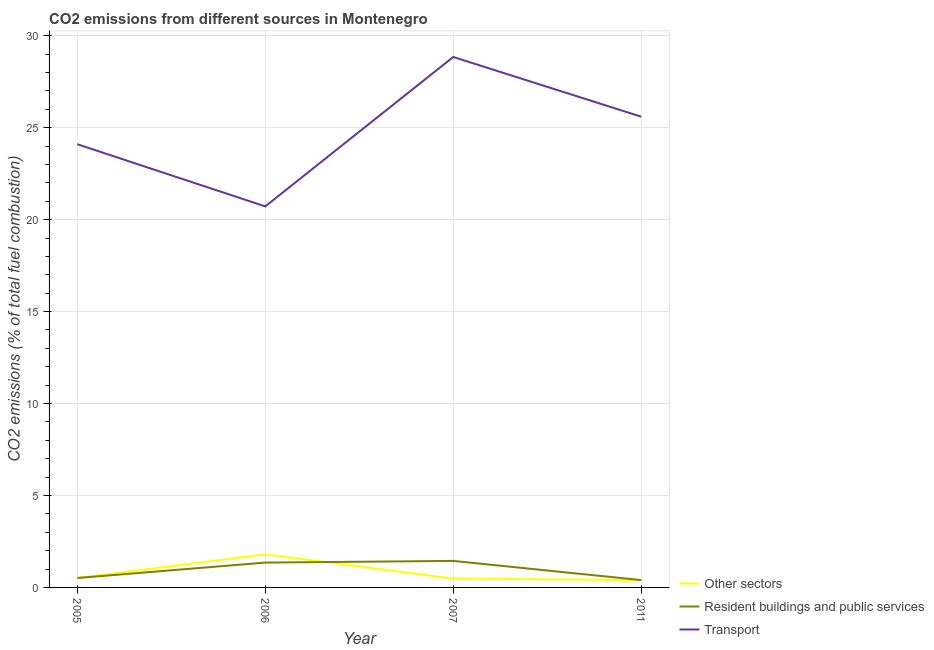What is the percentage of co2 emissions from resident buildings and public services in 2007?
Make the answer very short. 1.44. Across all years, what is the maximum percentage of co2 emissions from resident buildings and public services?
Your answer should be very brief. 1.44. Across all years, what is the minimum percentage of co2 emissions from other sectors?
Your answer should be very brief. 0.4. In which year was the percentage of co2 emissions from resident buildings and public services minimum?
Offer a very short reply. 2011. What is the total percentage of co2 emissions from resident buildings and public services in the graph?
Your answer should be compact. 3.71. What is the difference between the percentage of co2 emissions from resident buildings and public services in 2007 and that in 2011?
Offer a terse response. 1.04. What is the difference between the percentage of co2 emissions from resident buildings and public services in 2006 and the percentage of co2 emissions from transport in 2011?
Offer a terse response. -24.25. What is the average percentage of co2 emissions from other sectors per year?
Provide a short and direct response. 0.8. In the year 2007, what is the difference between the percentage of co2 emissions from other sectors and percentage of co2 emissions from transport?
Your answer should be very brief. -28.37. What is the ratio of the percentage of co2 emissions from transport in 2005 to that in 2011?
Your answer should be compact. 0.94. Is the percentage of co2 emissions from resident buildings and public services in 2005 less than that in 2007?
Make the answer very short. Yes. What is the difference between the highest and the second highest percentage of co2 emissions from resident buildings and public services?
Provide a short and direct response. 0.09. What is the difference between the highest and the lowest percentage of co2 emissions from other sectors?
Your answer should be very brief. 1.4. Does the percentage of co2 emissions from other sectors monotonically increase over the years?
Give a very brief answer. No. Is the percentage of co2 emissions from other sectors strictly greater than the percentage of co2 emissions from resident buildings and public services over the years?
Your answer should be compact. No. Is the percentage of co2 emissions from other sectors strictly less than the percentage of co2 emissions from resident buildings and public services over the years?
Offer a very short reply. No. What is the difference between two consecutive major ticks on the Y-axis?
Your answer should be compact. 5. Are the values on the major ticks of Y-axis written in scientific E-notation?
Ensure brevity in your answer.  No. Where does the legend appear in the graph?
Provide a succinct answer. Bottom right. How are the legend labels stacked?
Give a very brief answer. Vertical. What is the title of the graph?
Ensure brevity in your answer.  CO2 emissions from different sources in Montenegro. Does "Unemployment benefits" appear as one of the legend labels in the graph?
Offer a very short reply. No. What is the label or title of the X-axis?
Provide a succinct answer. Year. What is the label or title of the Y-axis?
Give a very brief answer. CO2 emissions (% of total fuel combustion). What is the CO2 emissions (% of total fuel combustion) in Other sectors in 2005?
Provide a succinct answer. 0.51. What is the CO2 emissions (% of total fuel combustion) of Resident buildings and public services in 2005?
Provide a short and direct response. 0.51. What is the CO2 emissions (% of total fuel combustion) in Transport in 2005?
Your answer should be compact. 24.1. What is the CO2 emissions (% of total fuel combustion) in Other sectors in 2006?
Keep it short and to the point. 1.8. What is the CO2 emissions (% of total fuel combustion) of Resident buildings and public services in 2006?
Give a very brief answer. 1.35. What is the CO2 emissions (% of total fuel combustion) in Transport in 2006?
Provide a short and direct response. 20.72. What is the CO2 emissions (% of total fuel combustion) in Other sectors in 2007?
Offer a very short reply. 0.48. What is the CO2 emissions (% of total fuel combustion) of Resident buildings and public services in 2007?
Your answer should be compact. 1.44. What is the CO2 emissions (% of total fuel combustion) of Transport in 2007?
Keep it short and to the point. 28.85. What is the CO2 emissions (% of total fuel combustion) in Transport in 2011?
Offer a terse response. 25.6. Across all years, what is the maximum CO2 emissions (% of total fuel combustion) in Other sectors?
Keep it short and to the point. 1.8. Across all years, what is the maximum CO2 emissions (% of total fuel combustion) in Resident buildings and public services?
Your answer should be compact. 1.44. Across all years, what is the maximum CO2 emissions (% of total fuel combustion) of Transport?
Your answer should be compact. 28.85. Across all years, what is the minimum CO2 emissions (% of total fuel combustion) of Other sectors?
Provide a succinct answer. 0.4. Across all years, what is the minimum CO2 emissions (% of total fuel combustion) of Transport?
Your response must be concise. 20.72. What is the total CO2 emissions (% of total fuel combustion) in Other sectors in the graph?
Offer a very short reply. 3.2. What is the total CO2 emissions (% of total fuel combustion) in Resident buildings and public services in the graph?
Offer a terse response. 3.71. What is the total CO2 emissions (% of total fuel combustion) in Transport in the graph?
Provide a succinct answer. 99.27. What is the difference between the CO2 emissions (% of total fuel combustion) of Other sectors in 2005 and that in 2006?
Provide a short and direct response. -1.29. What is the difference between the CO2 emissions (% of total fuel combustion) of Resident buildings and public services in 2005 and that in 2006?
Your response must be concise. -0.84. What is the difference between the CO2 emissions (% of total fuel combustion) in Transport in 2005 and that in 2006?
Your answer should be compact. 3.38. What is the difference between the CO2 emissions (% of total fuel combustion) in Other sectors in 2005 and that in 2007?
Offer a terse response. 0.03. What is the difference between the CO2 emissions (% of total fuel combustion) in Resident buildings and public services in 2005 and that in 2007?
Your answer should be very brief. -0.93. What is the difference between the CO2 emissions (% of total fuel combustion) in Transport in 2005 and that in 2007?
Offer a terse response. -4.74. What is the difference between the CO2 emissions (% of total fuel combustion) of Other sectors in 2005 and that in 2011?
Keep it short and to the point. 0.11. What is the difference between the CO2 emissions (% of total fuel combustion) of Resident buildings and public services in 2005 and that in 2011?
Provide a succinct answer. 0.11. What is the difference between the CO2 emissions (% of total fuel combustion) of Transport in 2005 and that in 2011?
Give a very brief answer. -1.5. What is the difference between the CO2 emissions (% of total fuel combustion) of Other sectors in 2006 and that in 2007?
Provide a short and direct response. 1.32. What is the difference between the CO2 emissions (% of total fuel combustion) in Resident buildings and public services in 2006 and that in 2007?
Provide a short and direct response. -0.09. What is the difference between the CO2 emissions (% of total fuel combustion) of Transport in 2006 and that in 2007?
Provide a succinct answer. -8.13. What is the difference between the CO2 emissions (% of total fuel combustion) of Other sectors in 2006 and that in 2011?
Provide a succinct answer. 1.4. What is the difference between the CO2 emissions (% of total fuel combustion) of Resident buildings and public services in 2006 and that in 2011?
Your response must be concise. 0.95. What is the difference between the CO2 emissions (% of total fuel combustion) in Transport in 2006 and that in 2011?
Give a very brief answer. -4.88. What is the difference between the CO2 emissions (% of total fuel combustion) of Other sectors in 2007 and that in 2011?
Give a very brief answer. 0.08. What is the difference between the CO2 emissions (% of total fuel combustion) of Resident buildings and public services in 2007 and that in 2011?
Provide a succinct answer. 1.04. What is the difference between the CO2 emissions (% of total fuel combustion) of Transport in 2007 and that in 2011?
Provide a short and direct response. 3.25. What is the difference between the CO2 emissions (% of total fuel combustion) of Other sectors in 2005 and the CO2 emissions (% of total fuel combustion) of Resident buildings and public services in 2006?
Offer a terse response. -0.84. What is the difference between the CO2 emissions (% of total fuel combustion) in Other sectors in 2005 and the CO2 emissions (% of total fuel combustion) in Transport in 2006?
Ensure brevity in your answer.  -20.21. What is the difference between the CO2 emissions (% of total fuel combustion) in Resident buildings and public services in 2005 and the CO2 emissions (% of total fuel combustion) in Transport in 2006?
Offer a very short reply. -20.21. What is the difference between the CO2 emissions (% of total fuel combustion) in Other sectors in 2005 and the CO2 emissions (% of total fuel combustion) in Resident buildings and public services in 2007?
Provide a short and direct response. -0.93. What is the difference between the CO2 emissions (% of total fuel combustion) of Other sectors in 2005 and the CO2 emissions (% of total fuel combustion) of Transport in 2007?
Offer a terse response. -28.33. What is the difference between the CO2 emissions (% of total fuel combustion) of Resident buildings and public services in 2005 and the CO2 emissions (% of total fuel combustion) of Transport in 2007?
Offer a terse response. -28.33. What is the difference between the CO2 emissions (% of total fuel combustion) of Other sectors in 2005 and the CO2 emissions (% of total fuel combustion) of Resident buildings and public services in 2011?
Your response must be concise. 0.11. What is the difference between the CO2 emissions (% of total fuel combustion) in Other sectors in 2005 and the CO2 emissions (% of total fuel combustion) in Transport in 2011?
Ensure brevity in your answer.  -25.09. What is the difference between the CO2 emissions (% of total fuel combustion) in Resident buildings and public services in 2005 and the CO2 emissions (% of total fuel combustion) in Transport in 2011?
Offer a very short reply. -25.09. What is the difference between the CO2 emissions (% of total fuel combustion) of Other sectors in 2006 and the CO2 emissions (% of total fuel combustion) of Resident buildings and public services in 2007?
Provide a short and direct response. 0.36. What is the difference between the CO2 emissions (% of total fuel combustion) in Other sectors in 2006 and the CO2 emissions (% of total fuel combustion) in Transport in 2007?
Your response must be concise. -27.04. What is the difference between the CO2 emissions (% of total fuel combustion) in Resident buildings and public services in 2006 and the CO2 emissions (% of total fuel combustion) in Transport in 2007?
Keep it short and to the point. -27.49. What is the difference between the CO2 emissions (% of total fuel combustion) of Other sectors in 2006 and the CO2 emissions (% of total fuel combustion) of Resident buildings and public services in 2011?
Keep it short and to the point. 1.4. What is the difference between the CO2 emissions (% of total fuel combustion) in Other sectors in 2006 and the CO2 emissions (% of total fuel combustion) in Transport in 2011?
Offer a terse response. -23.8. What is the difference between the CO2 emissions (% of total fuel combustion) of Resident buildings and public services in 2006 and the CO2 emissions (% of total fuel combustion) of Transport in 2011?
Provide a short and direct response. -24.25. What is the difference between the CO2 emissions (% of total fuel combustion) in Other sectors in 2007 and the CO2 emissions (% of total fuel combustion) in Resident buildings and public services in 2011?
Make the answer very short. 0.08. What is the difference between the CO2 emissions (% of total fuel combustion) of Other sectors in 2007 and the CO2 emissions (% of total fuel combustion) of Transport in 2011?
Make the answer very short. -25.12. What is the difference between the CO2 emissions (% of total fuel combustion) of Resident buildings and public services in 2007 and the CO2 emissions (% of total fuel combustion) of Transport in 2011?
Offer a terse response. -24.16. What is the average CO2 emissions (% of total fuel combustion) in Other sectors per year?
Make the answer very short. 0.8. What is the average CO2 emissions (% of total fuel combustion) in Resident buildings and public services per year?
Offer a very short reply. 0.93. What is the average CO2 emissions (% of total fuel combustion) of Transport per year?
Offer a terse response. 24.82. In the year 2005, what is the difference between the CO2 emissions (% of total fuel combustion) in Other sectors and CO2 emissions (% of total fuel combustion) in Resident buildings and public services?
Provide a succinct answer. 0. In the year 2005, what is the difference between the CO2 emissions (% of total fuel combustion) of Other sectors and CO2 emissions (% of total fuel combustion) of Transport?
Offer a terse response. -23.59. In the year 2005, what is the difference between the CO2 emissions (% of total fuel combustion) in Resident buildings and public services and CO2 emissions (% of total fuel combustion) in Transport?
Give a very brief answer. -23.59. In the year 2006, what is the difference between the CO2 emissions (% of total fuel combustion) of Other sectors and CO2 emissions (% of total fuel combustion) of Resident buildings and public services?
Your answer should be compact. 0.45. In the year 2006, what is the difference between the CO2 emissions (% of total fuel combustion) of Other sectors and CO2 emissions (% of total fuel combustion) of Transport?
Provide a short and direct response. -18.92. In the year 2006, what is the difference between the CO2 emissions (% of total fuel combustion) in Resident buildings and public services and CO2 emissions (% of total fuel combustion) in Transport?
Provide a short and direct response. -19.37. In the year 2007, what is the difference between the CO2 emissions (% of total fuel combustion) in Other sectors and CO2 emissions (% of total fuel combustion) in Resident buildings and public services?
Your response must be concise. -0.96. In the year 2007, what is the difference between the CO2 emissions (% of total fuel combustion) of Other sectors and CO2 emissions (% of total fuel combustion) of Transport?
Make the answer very short. -28.37. In the year 2007, what is the difference between the CO2 emissions (% of total fuel combustion) in Resident buildings and public services and CO2 emissions (% of total fuel combustion) in Transport?
Your answer should be very brief. -27.4. In the year 2011, what is the difference between the CO2 emissions (% of total fuel combustion) of Other sectors and CO2 emissions (% of total fuel combustion) of Resident buildings and public services?
Your answer should be compact. 0. In the year 2011, what is the difference between the CO2 emissions (% of total fuel combustion) of Other sectors and CO2 emissions (% of total fuel combustion) of Transport?
Make the answer very short. -25.2. In the year 2011, what is the difference between the CO2 emissions (% of total fuel combustion) in Resident buildings and public services and CO2 emissions (% of total fuel combustion) in Transport?
Your response must be concise. -25.2. What is the ratio of the CO2 emissions (% of total fuel combustion) in Other sectors in 2005 to that in 2006?
Give a very brief answer. 0.28. What is the ratio of the CO2 emissions (% of total fuel combustion) in Resident buildings and public services in 2005 to that in 2006?
Offer a very short reply. 0.38. What is the ratio of the CO2 emissions (% of total fuel combustion) in Transport in 2005 to that in 2006?
Offer a terse response. 1.16. What is the ratio of the CO2 emissions (% of total fuel combustion) in Other sectors in 2005 to that in 2007?
Offer a terse response. 1.07. What is the ratio of the CO2 emissions (% of total fuel combustion) in Resident buildings and public services in 2005 to that in 2007?
Provide a short and direct response. 0.36. What is the ratio of the CO2 emissions (% of total fuel combustion) in Transport in 2005 to that in 2007?
Your answer should be very brief. 0.84. What is the ratio of the CO2 emissions (% of total fuel combustion) in Other sectors in 2005 to that in 2011?
Your answer should be very brief. 1.28. What is the ratio of the CO2 emissions (% of total fuel combustion) of Resident buildings and public services in 2005 to that in 2011?
Keep it short and to the point. 1.28. What is the ratio of the CO2 emissions (% of total fuel combustion) of Transport in 2005 to that in 2011?
Offer a terse response. 0.94. What is the ratio of the CO2 emissions (% of total fuel combustion) in Other sectors in 2006 to that in 2007?
Your answer should be very brief. 3.75. What is the ratio of the CO2 emissions (% of total fuel combustion) of Resident buildings and public services in 2006 to that in 2007?
Keep it short and to the point. 0.94. What is the ratio of the CO2 emissions (% of total fuel combustion) of Transport in 2006 to that in 2007?
Offer a terse response. 0.72. What is the ratio of the CO2 emissions (% of total fuel combustion) of Other sectors in 2006 to that in 2011?
Offer a terse response. 4.5. What is the ratio of the CO2 emissions (% of total fuel combustion) in Resident buildings and public services in 2006 to that in 2011?
Your answer should be compact. 3.38. What is the ratio of the CO2 emissions (% of total fuel combustion) in Transport in 2006 to that in 2011?
Make the answer very short. 0.81. What is the ratio of the CO2 emissions (% of total fuel combustion) in Other sectors in 2007 to that in 2011?
Offer a terse response. 1.2. What is the ratio of the CO2 emissions (% of total fuel combustion) of Resident buildings and public services in 2007 to that in 2011?
Keep it short and to the point. 3.61. What is the ratio of the CO2 emissions (% of total fuel combustion) of Transport in 2007 to that in 2011?
Ensure brevity in your answer.  1.13. What is the difference between the highest and the second highest CO2 emissions (% of total fuel combustion) in Other sectors?
Provide a short and direct response. 1.29. What is the difference between the highest and the second highest CO2 emissions (% of total fuel combustion) of Resident buildings and public services?
Keep it short and to the point. 0.09. What is the difference between the highest and the second highest CO2 emissions (% of total fuel combustion) of Transport?
Offer a very short reply. 3.25. What is the difference between the highest and the lowest CO2 emissions (% of total fuel combustion) of Other sectors?
Keep it short and to the point. 1.4. What is the difference between the highest and the lowest CO2 emissions (% of total fuel combustion) in Resident buildings and public services?
Ensure brevity in your answer.  1.04. What is the difference between the highest and the lowest CO2 emissions (% of total fuel combustion) in Transport?
Ensure brevity in your answer.  8.13. 